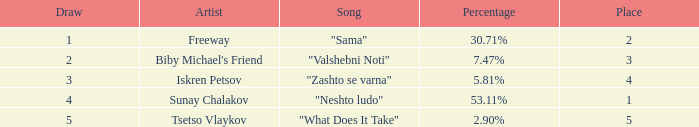What is the least draw when the place is higher than 4? 5.0. 